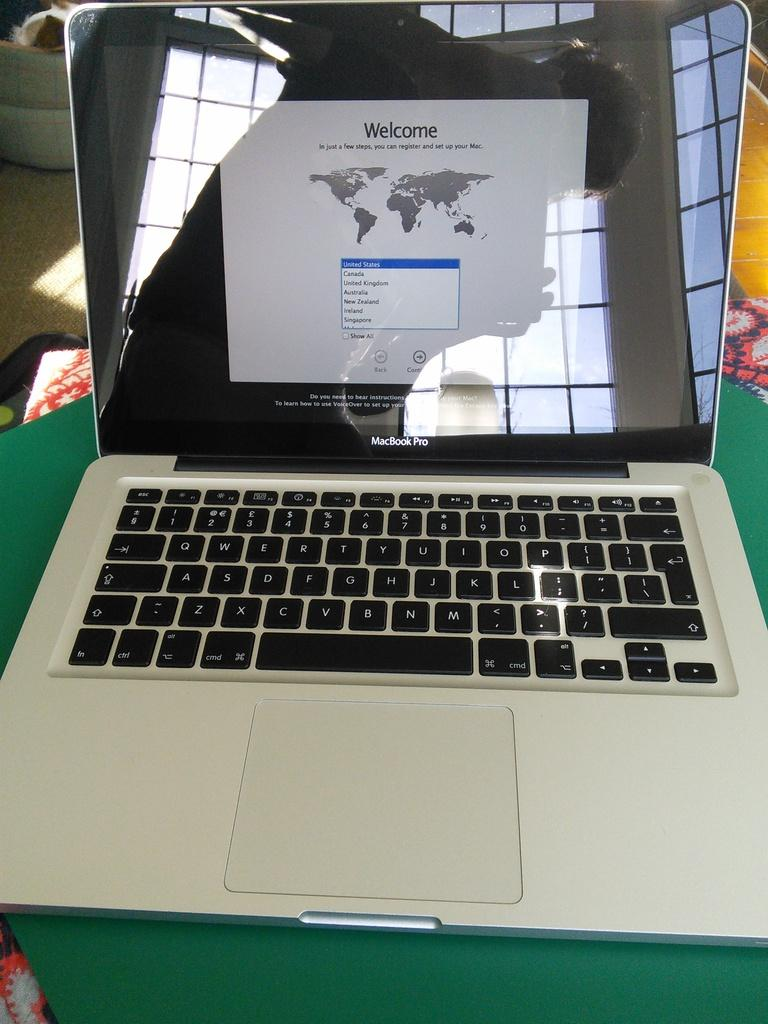Provide a one-sentence caption for the provided image. macbook pro with the registration welcome page on the screen. 